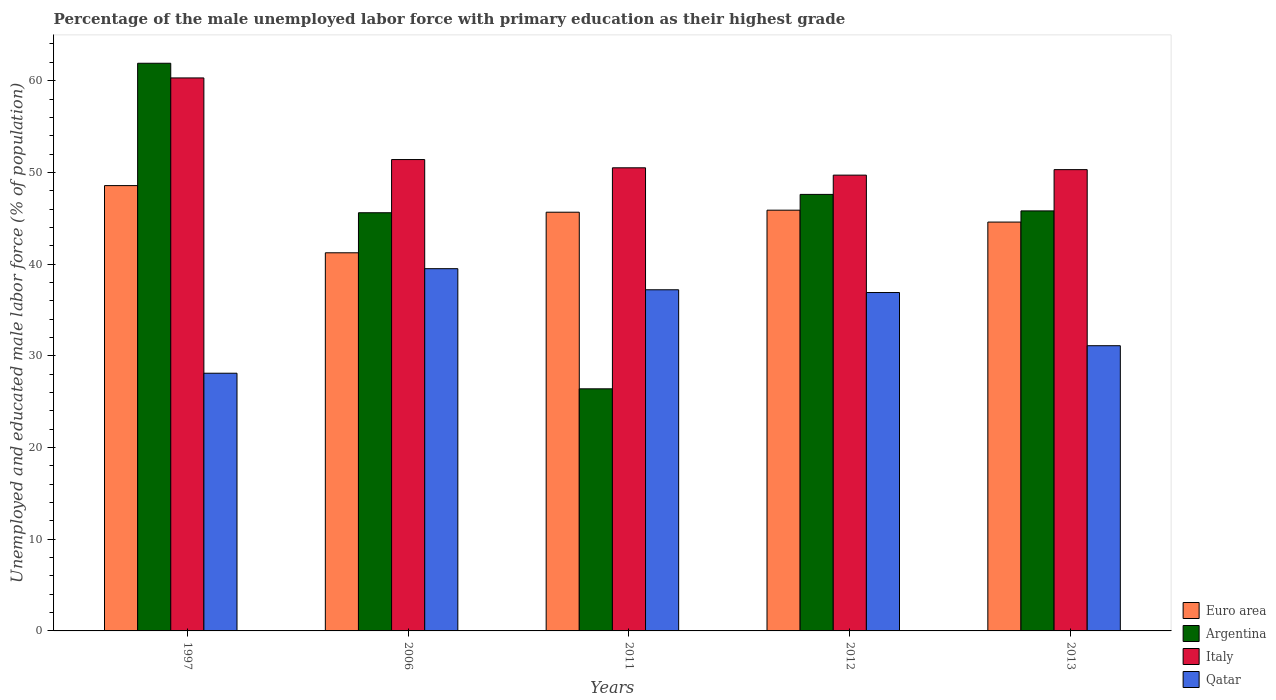How many different coloured bars are there?
Give a very brief answer. 4. How many groups of bars are there?
Offer a terse response. 5. Are the number of bars per tick equal to the number of legend labels?
Offer a terse response. Yes. How many bars are there on the 4th tick from the left?
Provide a short and direct response. 4. In how many cases, is the number of bars for a given year not equal to the number of legend labels?
Your answer should be compact. 0. What is the percentage of the unemployed male labor force with primary education in Euro area in 2013?
Your answer should be very brief. 44.58. Across all years, what is the maximum percentage of the unemployed male labor force with primary education in Argentina?
Your answer should be very brief. 61.9. Across all years, what is the minimum percentage of the unemployed male labor force with primary education in Qatar?
Provide a succinct answer. 28.1. In which year was the percentage of the unemployed male labor force with primary education in Qatar minimum?
Offer a very short reply. 1997. What is the total percentage of the unemployed male labor force with primary education in Italy in the graph?
Keep it short and to the point. 262.2. What is the difference between the percentage of the unemployed male labor force with primary education in Qatar in 1997 and that in 2012?
Provide a succinct answer. -8.8. What is the difference between the percentage of the unemployed male labor force with primary education in Euro area in 2006 and the percentage of the unemployed male labor force with primary education in Italy in 2013?
Your answer should be compact. -9.07. What is the average percentage of the unemployed male labor force with primary education in Italy per year?
Your answer should be compact. 52.44. In the year 2006, what is the difference between the percentage of the unemployed male labor force with primary education in Qatar and percentage of the unemployed male labor force with primary education in Italy?
Your answer should be very brief. -11.9. What is the ratio of the percentage of the unemployed male labor force with primary education in Euro area in 2011 to that in 2012?
Keep it short and to the point. 1. Is the percentage of the unemployed male labor force with primary education in Italy in 2012 less than that in 2013?
Offer a very short reply. Yes. What is the difference between the highest and the second highest percentage of the unemployed male labor force with primary education in Qatar?
Give a very brief answer. 2.3. What is the difference between the highest and the lowest percentage of the unemployed male labor force with primary education in Italy?
Your answer should be very brief. 10.6. In how many years, is the percentage of the unemployed male labor force with primary education in Qatar greater than the average percentage of the unemployed male labor force with primary education in Qatar taken over all years?
Offer a very short reply. 3. Is the sum of the percentage of the unemployed male labor force with primary education in Qatar in 2012 and 2013 greater than the maximum percentage of the unemployed male labor force with primary education in Italy across all years?
Give a very brief answer. Yes. What does the 1st bar from the left in 2006 represents?
Your answer should be very brief. Euro area. What does the 2nd bar from the right in 1997 represents?
Your answer should be very brief. Italy. Is it the case that in every year, the sum of the percentage of the unemployed male labor force with primary education in Italy and percentage of the unemployed male labor force with primary education in Argentina is greater than the percentage of the unemployed male labor force with primary education in Euro area?
Offer a terse response. Yes. How many bars are there?
Give a very brief answer. 20. Are all the bars in the graph horizontal?
Offer a very short reply. No. Does the graph contain any zero values?
Give a very brief answer. No. Does the graph contain grids?
Keep it short and to the point. No. How many legend labels are there?
Give a very brief answer. 4. How are the legend labels stacked?
Your answer should be compact. Vertical. What is the title of the graph?
Your response must be concise. Percentage of the male unemployed labor force with primary education as their highest grade. Does "Peru" appear as one of the legend labels in the graph?
Your response must be concise. No. What is the label or title of the X-axis?
Provide a succinct answer. Years. What is the label or title of the Y-axis?
Offer a very short reply. Unemployed and educated male labor force (% of population). What is the Unemployed and educated male labor force (% of population) of Euro area in 1997?
Your response must be concise. 48.56. What is the Unemployed and educated male labor force (% of population) in Argentina in 1997?
Provide a succinct answer. 61.9. What is the Unemployed and educated male labor force (% of population) of Italy in 1997?
Your answer should be very brief. 60.3. What is the Unemployed and educated male labor force (% of population) of Qatar in 1997?
Provide a succinct answer. 28.1. What is the Unemployed and educated male labor force (% of population) in Euro area in 2006?
Offer a very short reply. 41.23. What is the Unemployed and educated male labor force (% of population) of Argentina in 2006?
Provide a short and direct response. 45.6. What is the Unemployed and educated male labor force (% of population) of Italy in 2006?
Offer a terse response. 51.4. What is the Unemployed and educated male labor force (% of population) of Qatar in 2006?
Your answer should be very brief. 39.5. What is the Unemployed and educated male labor force (% of population) in Euro area in 2011?
Your answer should be very brief. 45.66. What is the Unemployed and educated male labor force (% of population) of Argentina in 2011?
Keep it short and to the point. 26.4. What is the Unemployed and educated male labor force (% of population) in Italy in 2011?
Your answer should be very brief. 50.5. What is the Unemployed and educated male labor force (% of population) in Qatar in 2011?
Your response must be concise. 37.2. What is the Unemployed and educated male labor force (% of population) in Euro area in 2012?
Give a very brief answer. 45.88. What is the Unemployed and educated male labor force (% of population) of Argentina in 2012?
Provide a succinct answer. 47.6. What is the Unemployed and educated male labor force (% of population) of Italy in 2012?
Your answer should be compact. 49.7. What is the Unemployed and educated male labor force (% of population) of Qatar in 2012?
Your response must be concise. 36.9. What is the Unemployed and educated male labor force (% of population) of Euro area in 2013?
Make the answer very short. 44.58. What is the Unemployed and educated male labor force (% of population) of Argentina in 2013?
Ensure brevity in your answer.  45.8. What is the Unemployed and educated male labor force (% of population) of Italy in 2013?
Give a very brief answer. 50.3. What is the Unemployed and educated male labor force (% of population) of Qatar in 2013?
Your answer should be very brief. 31.1. Across all years, what is the maximum Unemployed and educated male labor force (% of population) in Euro area?
Make the answer very short. 48.56. Across all years, what is the maximum Unemployed and educated male labor force (% of population) of Argentina?
Give a very brief answer. 61.9. Across all years, what is the maximum Unemployed and educated male labor force (% of population) in Italy?
Provide a succinct answer. 60.3. Across all years, what is the maximum Unemployed and educated male labor force (% of population) of Qatar?
Offer a terse response. 39.5. Across all years, what is the minimum Unemployed and educated male labor force (% of population) of Euro area?
Provide a short and direct response. 41.23. Across all years, what is the minimum Unemployed and educated male labor force (% of population) of Argentina?
Make the answer very short. 26.4. Across all years, what is the minimum Unemployed and educated male labor force (% of population) of Italy?
Your answer should be very brief. 49.7. Across all years, what is the minimum Unemployed and educated male labor force (% of population) of Qatar?
Your response must be concise. 28.1. What is the total Unemployed and educated male labor force (% of population) in Euro area in the graph?
Your response must be concise. 225.91. What is the total Unemployed and educated male labor force (% of population) of Argentina in the graph?
Your response must be concise. 227.3. What is the total Unemployed and educated male labor force (% of population) in Italy in the graph?
Provide a succinct answer. 262.2. What is the total Unemployed and educated male labor force (% of population) of Qatar in the graph?
Keep it short and to the point. 172.8. What is the difference between the Unemployed and educated male labor force (% of population) of Euro area in 1997 and that in 2006?
Provide a short and direct response. 7.33. What is the difference between the Unemployed and educated male labor force (% of population) in Argentina in 1997 and that in 2006?
Make the answer very short. 16.3. What is the difference between the Unemployed and educated male labor force (% of population) of Italy in 1997 and that in 2006?
Make the answer very short. 8.9. What is the difference between the Unemployed and educated male labor force (% of population) of Qatar in 1997 and that in 2006?
Provide a short and direct response. -11.4. What is the difference between the Unemployed and educated male labor force (% of population) of Euro area in 1997 and that in 2011?
Your response must be concise. 2.9. What is the difference between the Unemployed and educated male labor force (% of population) in Argentina in 1997 and that in 2011?
Your answer should be very brief. 35.5. What is the difference between the Unemployed and educated male labor force (% of population) of Euro area in 1997 and that in 2012?
Ensure brevity in your answer.  2.68. What is the difference between the Unemployed and educated male labor force (% of population) of Italy in 1997 and that in 2012?
Ensure brevity in your answer.  10.6. What is the difference between the Unemployed and educated male labor force (% of population) in Qatar in 1997 and that in 2012?
Your response must be concise. -8.8. What is the difference between the Unemployed and educated male labor force (% of population) of Euro area in 1997 and that in 2013?
Ensure brevity in your answer.  3.98. What is the difference between the Unemployed and educated male labor force (% of population) of Argentina in 1997 and that in 2013?
Keep it short and to the point. 16.1. What is the difference between the Unemployed and educated male labor force (% of population) of Euro area in 2006 and that in 2011?
Provide a succinct answer. -4.42. What is the difference between the Unemployed and educated male labor force (% of population) in Argentina in 2006 and that in 2011?
Make the answer very short. 19.2. What is the difference between the Unemployed and educated male labor force (% of population) in Qatar in 2006 and that in 2011?
Keep it short and to the point. 2.3. What is the difference between the Unemployed and educated male labor force (% of population) of Euro area in 2006 and that in 2012?
Your response must be concise. -4.65. What is the difference between the Unemployed and educated male labor force (% of population) of Argentina in 2006 and that in 2012?
Keep it short and to the point. -2. What is the difference between the Unemployed and educated male labor force (% of population) of Italy in 2006 and that in 2012?
Keep it short and to the point. 1.7. What is the difference between the Unemployed and educated male labor force (% of population) in Qatar in 2006 and that in 2012?
Your answer should be compact. 2.6. What is the difference between the Unemployed and educated male labor force (% of population) in Euro area in 2006 and that in 2013?
Ensure brevity in your answer.  -3.35. What is the difference between the Unemployed and educated male labor force (% of population) in Argentina in 2006 and that in 2013?
Your response must be concise. -0.2. What is the difference between the Unemployed and educated male labor force (% of population) in Italy in 2006 and that in 2013?
Your answer should be compact. 1.1. What is the difference between the Unemployed and educated male labor force (% of population) in Qatar in 2006 and that in 2013?
Ensure brevity in your answer.  8.4. What is the difference between the Unemployed and educated male labor force (% of population) of Euro area in 2011 and that in 2012?
Your answer should be very brief. -0.22. What is the difference between the Unemployed and educated male labor force (% of population) of Argentina in 2011 and that in 2012?
Offer a terse response. -21.2. What is the difference between the Unemployed and educated male labor force (% of population) of Italy in 2011 and that in 2012?
Your answer should be very brief. 0.8. What is the difference between the Unemployed and educated male labor force (% of population) in Qatar in 2011 and that in 2012?
Provide a succinct answer. 0.3. What is the difference between the Unemployed and educated male labor force (% of population) of Euro area in 2011 and that in 2013?
Your answer should be compact. 1.08. What is the difference between the Unemployed and educated male labor force (% of population) in Argentina in 2011 and that in 2013?
Your answer should be very brief. -19.4. What is the difference between the Unemployed and educated male labor force (% of population) of Euro area in 2012 and that in 2013?
Your response must be concise. 1.3. What is the difference between the Unemployed and educated male labor force (% of population) of Argentina in 2012 and that in 2013?
Give a very brief answer. 1.8. What is the difference between the Unemployed and educated male labor force (% of population) in Italy in 2012 and that in 2013?
Give a very brief answer. -0.6. What is the difference between the Unemployed and educated male labor force (% of population) of Euro area in 1997 and the Unemployed and educated male labor force (% of population) of Argentina in 2006?
Give a very brief answer. 2.96. What is the difference between the Unemployed and educated male labor force (% of population) in Euro area in 1997 and the Unemployed and educated male labor force (% of population) in Italy in 2006?
Make the answer very short. -2.84. What is the difference between the Unemployed and educated male labor force (% of population) in Euro area in 1997 and the Unemployed and educated male labor force (% of population) in Qatar in 2006?
Your answer should be compact. 9.06. What is the difference between the Unemployed and educated male labor force (% of population) of Argentina in 1997 and the Unemployed and educated male labor force (% of population) of Italy in 2006?
Your response must be concise. 10.5. What is the difference between the Unemployed and educated male labor force (% of population) of Argentina in 1997 and the Unemployed and educated male labor force (% of population) of Qatar in 2006?
Offer a terse response. 22.4. What is the difference between the Unemployed and educated male labor force (% of population) in Italy in 1997 and the Unemployed and educated male labor force (% of population) in Qatar in 2006?
Your answer should be very brief. 20.8. What is the difference between the Unemployed and educated male labor force (% of population) in Euro area in 1997 and the Unemployed and educated male labor force (% of population) in Argentina in 2011?
Your response must be concise. 22.16. What is the difference between the Unemployed and educated male labor force (% of population) in Euro area in 1997 and the Unemployed and educated male labor force (% of population) in Italy in 2011?
Your answer should be very brief. -1.94. What is the difference between the Unemployed and educated male labor force (% of population) in Euro area in 1997 and the Unemployed and educated male labor force (% of population) in Qatar in 2011?
Ensure brevity in your answer.  11.36. What is the difference between the Unemployed and educated male labor force (% of population) in Argentina in 1997 and the Unemployed and educated male labor force (% of population) in Italy in 2011?
Ensure brevity in your answer.  11.4. What is the difference between the Unemployed and educated male labor force (% of population) in Argentina in 1997 and the Unemployed and educated male labor force (% of population) in Qatar in 2011?
Offer a very short reply. 24.7. What is the difference between the Unemployed and educated male labor force (% of population) in Italy in 1997 and the Unemployed and educated male labor force (% of population) in Qatar in 2011?
Provide a short and direct response. 23.1. What is the difference between the Unemployed and educated male labor force (% of population) of Euro area in 1997 and the Unemployed and educated male labor force (% of population) of Argentina in 2012?
Provide a succinct answer. 0.96. What is the difference between the Unemployed and educated male labor force (% of population) of Euro area in 1997 and the Unemployed and educated male labor force (% of population) of Italy in 2012?
Your response must be concise. -1.14. What is the difference between the Unemployed and educated male labor force (% of population) in Euro area in 1997 and the Unemployed and educated male labor force (% of population) in Qatar in 2012?
Your answer should be compact. 11.66. What is the difference between the Unemployed and educated male labor force (% of population) in Argentina in 1997 and the Unemployed and educated male labor force (% of population) in Qatar in 2012?
Ensure brevity in your answer.  25. What is the difference between the Unemployed and educated male labor force (% of population) of Italy in 1997 and the Unemployed and educated male labor force (% of population) of Qatar in 2012?
Ensure brevity in your answer.  23.4. What is the difference between the Unemployed and educated male labor force (% of population) in Euro area in 1997 and the Unemployed and educated male labor force (% of population) in Argentina in 2013?
Your answer should be compact. 2.76. What is the difference between the Unemployed and educated male labor force (% of population) of Euro area in 1997 and the Unemployed and educated male labor force (% of population) of Italy in 2013?
Offer a terse response. -1.74. What is the difference between the Unemployed and educated male labor force (% of population) in Euro area in 1997 and the Unemployed and educated male labor force (% of population) in Qatar in 2013?
Ensure brevity in your answer.  17.46. What is the difference between the Unemployed and educated male labor force (% of population) of Argentina in 1997 and the Unemployed and educated male labor force (% of population) of Qatar in 2013?
Give a very brief answer. 30.8. What is the difference between the Unemployed and educated male labor force (% of population) of Italy in 1997 and the Unemployed and educated male labor force (% of population) of Qatar in 2013?
Give a very brief answer. 29.2. What is the difference between the Unemployed and educated male labor force (% of population) in Euro area in 2006 and the Unemployed and educated male labor force (% of population) in Argentina in 2011?
Offer a terse response. 14.83. What is the difference between the Unemployed and educated male labor force (% of population) of Euro area in 2006 and the Unemployed and educated male labor force (% of population) of Italy in 2011?
Your response must be concise. -9.27. What is the difference between the Unemployed and educated male labor force (% of population) in Euro area in 2006 and the Unemployed and educated male labor force (% of population) in Qatar in 2011?
Ensure brevity in your answer.  4.03. What is the difference between the Unemployed and educated male labor force (% of population) in Argentina in 2006 and the Unemployed and educated male labor force (% of population) in Italy in 2011?
Offer a very short reply. -4.9. What is the difference between the Unemployed and educated male labor force (% of population) of Italy in 2006 and the Unemployed and educated male labor force (% of population) of Qatar in 2011?
Your answer should be compact. 14.2. What is the difference between the Unemployed and educated male labor force (% of population) of Euro area in 2006 and the Unemployed and educated male labor force (% of population) of Argentina in 2012?
Your response must be concise. -6.37. What is the difference between the Unemployed and educated male labor force (% of population) in Euro area in 2006 and the Unemployed and educated male labor force (% of population) in Italy in 2012?
Give a very brief answer. -8.47. What is the difference between the Unemployed and educated male labor force (% of population) of Euro area in 2006 and the Unemployed and educated male labor force (% of population) of Qatar in 2012?
Provide a short and direct response. 4.33. What is the difference between the Unemployed and educated male labor force (% of population) of Argentina in 2006 and the Unemployed and educated male labor force (% of population) of Qatar in 2012?
Your answer should be very brief. 8.7. What is the difference between the Unemployed and educated male labor force (% of population) in Euro area in 2006 and the Unemployed and educated male labor force (% of population) in Argentina in 2013?
Ensure brevity in your answer.  -4.57. What is the difference between the Unemployed and educated male labor force (% of population) of Euro area in 2006 and the Unemployed and educated male labor force (% of population) of Italy in 2013?
Your answer should be very brief. -9.07. What is the difference between the Unemployed and educated male labor force (% of population) in Euro area in 2006 and the Unemployed and educated male labor force (% of population) in Qatar in 2013?
Make the answer very short. 10.13. What is the difference between the Unemployed and educated male labor force (% of population) of Argentina in 2006 and the Unemployed and educated male labor force (% of population) of Qatar in 2013?
Offer a terse response. 14.5. What is the difference between the Unemployed and educated male labor force (% of population) of Italy in 2006 and the Unemployed and educated male labor force (% of population) of Qatar in 2013?
Offer a very short reply. 20.3. What is the difference between the Unemployed and educated male labor force (% of population) of Euro area in 2011 and the Unemployed and educated male labor force (% of population) of Argentina in 2012?
Offer a very short reply. -1.94. What is the difference between the Unemployed and educated male labor force (% of population) in Euro area in 2011 and the Unemployed and educated male labor force (% of population) in Italy in 2012?
Give a very brief answer. -4.04. What is the difference between the Unemployed and educated male labor force (% of population) in Euro area in 2011 and the Unemployed and educated male labor force (% of population) in Qatar in 2012?
Offer a terse response. 8.76. What is the difference between the Unemployed and educated male labor force (% of population) in Argentina in 2011 and the Unemployed and educated male labor force (% of population) in Italy in 2012?
Offer a terse response. -23.3. What is the difference between the Unemployed and educated male labor force (% of population) in Italy in 2011 and the Unemployed and educated male labor force (% of population) in Qatar in 2012?
Give a very brief answer. 13.6. What is the difference between the Unemployed and educated male labor force (% of population) in Euro area in 2011 and the Unemployed and educated male labor force (% of population) in Argentina in 2013?
Ensure brevity in your answer.  -0.14. What is the difference between the Unemployed and educated male labor force (% of population) in Euro area in 2011 and the Unemployed and educated male labor force (% of population) in Italy in 2013?
Your response must be concise. -4.64. What is the difference between the Unemployed and educated male labor force (% of population) of Euro area in 2011 and the Unemployed and educated male labor force (% of population) of Qatar in 2013?
Ensure brevity in your answer.  14.56. What is the difference between the Unemployed and educated male labor force (% of population) of Argentina in 2011 and the Unemployed and educated male labor force (% of population) of Italy in 2013?
Offer a very short reply. -23.9. What is the difference between the Unemployed and educated male labor force (% of population) in Argentina in 2011 and the Unemployed and educated male labor force (% of population) in Qatar in 2013?
Ensure brevity in your answer.  -4.7. What is the difference between the Unemployed and educated male labor force (% of population) of Euro area in 2012 and the Unemployed and educated male labor force (% of population) of Argentina in 2013?
Your response must be concise. 0.08. What is the difference between the Unemployed and educated male labor force (% of population) of Euro area in 2012 and the Unemployed and educated male labor force (% of population) of Italy in 2013?
Offer a terse response. -4.42. What is the difference between the Unemployed and educated male labor force (% of population) of Euro area in 2012 and the Unemployed and educated male labor force (% of population) of Qatar in 2013?
Keep it short and to the point. 14.78. What is the difference between the Unemployed and educated male labor force (% of population) of Argentina in 2012 and the Unemployed and educated male labor force (% of population) of Italy in 2013?
Your response must be concise. -2.7. What is the difference between the Unemployed and educated male labor force (% of population) in Argentina in 2012 and the Unemployed and educated male labor force (% of population) in Qatar in 2013?
Provide a succinct answer. 16.5. What is the difference between the Unemployed and educated male labor force (% of population) in Italy in 2012 and the Unemployed and educated male labor force (% of population) in Qatar in 2013?
Offer a very short reply. 18.6. What is the average Unemployed and educated male labor force (% of population) in Euro area per year?
Make the answer very short. 45.18. What is the average Unemployed and educated male labor force (% of population) of Argentina per year?
Offer a terse response. 45.46. What is the average Unemployed and educated male labor force (% of population) in Italy per year?
Provide a succinct answer. 52.44. What is the average Unemployed and educated male labor force (% of population) in Qatar per year?
Provide a short and direct response. 34.56. In the year 1997, what is the difference between the Unemployed and educated male labor force (% of population) in Euro area and Unemployed and educated male labor force (% of population) in Argentina?
Provide a short and direct response. -13.34. In the year 1997, what is the difference between the Unemployed and educated male labor force (% of population) in Euro area and Unemployed and educated male labor force (% of population) in Italy?
Keep it short and to the point. -11.74. In the year 1997, what is the difference between the Unemployed and educated male labor force (% of population) in Euro area and Unemployed and educated male labor force (% of population) in Qatar?
Keep it short and to the point. 20.46. In the year 1997, what is the difference between the Unemployed and educated male labor force (% of population) in Argentina and Unemployed and educated male labor force (% of population) in Qatar?
Ensure brevity in your answer.  33.8. In the year 1997, what is the difference between the Unemployed and educated male labor force (% of population) of Italy and Unemployed and educated male labor force (% of population) of Qatar?
Give a very brief answer. 32.2. In the year 2006, what is the difference between the Unemployed and educated male labor force (% of population) in Euro area and Unemployed and educated male labor force (% of population) in Argentina?
Keep it short and to the point. -4.37. In the year 2006, what is the difference between the Unemployed and educated male labor force (% of population) of Euro area and Unemployed and educated male labor force (% of population) of Italy?
Your response must be concise. -10.17. In the year 2006, what is the difference between the Unemployed and educated male labor force (% of population) of Euro area and Unemployed and educated male labor force (% of population) of Qatar?
Your answer should be very brief. 1.73. In the year 2006, what is the difference between the Unemployed and educated male labor force (% of population) of Argentina and Unemployed and educated male labor force (% of population) of Qatar?
Offer a very short reply. 6.1. In the year 2006, what is the difference between the Unemployed and educated male labor force (% of population) in Italy and Unemployed and educated male labor force (% of population) in Qatar?
Offer a terse response. 11.9. In the year 2011, what is the difference between the Unemployed and educated male labor force (% of population) in Euro area and Unemployed and educated male labor force (% of population) in Argentina?
Give a very brief answer. 19.26. In the year 2011, what is the difference between the Unemployed and educated male labor force (% of population) of Euro area and Unemployed and educated male labor force (% of population) of Italy?
Ensure brevity in your answer.  -4.84. In the year 2011, what is the difference between the Unemployed and educated male labor force (% of population) of Euro area and Unemployed and educated male labor force (% of population) of Qatar?
Your answer should be very brief. 8.46. In the year 2011, what is the difference between the Unemployed and educated male labor force (% of population) in Argentina and Unemployed and educated male labor force (% of population) in Italy?
Your answer should be very brief. -24.1. In the year 2012, what is the difference between the Unemployed and educated male labor force (% of population) in Euro area and Unemployed and educated male labor force (% of population) in Argentina?
Give a very brief answer. -1.72. In the year 2012, what is the difference between the Unemployed and educated male labor force (% of population) of Euro area and Unemployed and educated male labor force (% of population) of Italy?
Provide a short and direct response. -3.82. In the year 2012, what is the difference between the Unemployed and educated male labor force (% of population) in Euro area and Unemployed and educated male labor force (% of population) in Qatar?
Keep it short and to the point. 8.98. In the year 2012, what is the difference between the Unemployed and educated male labor force (% of population) of Argentina and Unemployed and educated male labor force (% of population) of Italy?
Keep it short and to the point. -2.1. In the year 2012, what is the difference between the Unemployed and educated male labor force (% of population) of Argentina and Unemployed and educated male labor force (% of population) of Qatar?
Your answer should be very brief. 10.7. In the year 2012, what is the difference between the Unemployed and educated male labor force (% of population) of Italy and Unemployed and educated male labor force (% of population) of Qatar?
Your answer should be compact. 12.8. In the year 2013, what is the difference between the Unemployed and educated male labor force (% of population) of Euro area and Unemployed and educated male labor force (% of population) of Argentina?
Offer a very short reply. -1.22. In the year 2013, what is the difference between the Unemployed and educated male labor force (% of population) in Euro area and Unemployed and educated male labor force (% of population) in Italy?
Ensure brevity in your answer.  -5.72. In the year 2013, what is the difference between the Unemployed and educated male labor force (% of population) in Euro area and Unemployed and educated male labor force (% of population) in Qatar?
Ensure brevity in your answer.  13.48. What is the ratio of the Unemployed and educated male labor force (% of population) of Euro area in 1997 to that in 2006?
Ensure brevity in your answer.  1.18. What is the ratio of the Unemployed and educated male labor force (% of population) of Argentina in 1997 to that in 2006?
Your answer should be very brief. 1.36. What is the ratio of the Unemployed and educated male labor force (% of population) in Italy in 1997 to that in 2006?
Give a very brief answer. 1.17. What is the ratio of the Unemployed and educated male labor force (% of population) of Qatar in 1997 to that in 2006?
Your answer should be very brief. 0.71. What is the ratio of the Unemployed and educated male labor force (% of population) of Euro area in 1997 to that in 2011?
Offer a very short reply. 1.06. What is the ratio of the Unemployed and educated male labor force (% of population) of Argentina in 1997 to that in 2011?
Your answer should be compact. 2.34. What is the ratio of the Unemployed and educated male labor force (% of population) of Italy in 1997 to that in 2011?
Your answer should be very brief. 1.19. What is the ratio of the Unemployed and educated male labor force (% of population) in Qatar in 1997 to that in 2011?
Your answer should be very brief. 0.76. What is the ratio of the Unemployed and educated male labor force (% of population) of Euro area in 1997 to that in 2012?
Your response must be concise. 1.06. What is the ratio of the Unemployed and educated male labor force (% of population) in Argentina in 1997 to that in 2012?
Offer a terse response. 1.3. What is the ratio of the Unemployed and educated male labor force (% of population) of Italy in 1997 to that in 2012?
Your answer should be very brief. 1.21. What is the ratio of the Unemployed and educated male labor force (% of population) of Qatar in 1997 to that in 2012?
Ensure brevity in your answer.  0.76. What is the ratio of the Unemployed and educated male labor force (% of population) in Euro area in 1997 to that in 2013?
Your answer should be very brief. 1.09. What is the ratio of the Unemployed and educated male labor force (% of population) of Argentina in 1997 to that in 2013?
Your answer should be very brief. 1.35. What is the ratio of the Unemployed and educated male labor force (% of population) of Italy in 1997 to that in 2013?
Your response must be concise. 1.2. What is the ratio of the Unemployed and educated male labor force (% of population) in Qatar in 1997 to that in 2013?
Make the answer very short. 0.9. What is the ratio of the Unemployed and educated male labor force (% of population) in Euro area in 2006 to that in 2011?
Give a very brief answer. 0.9. What is the ratio of the Unemployed and educated male labor force (% of population) of Argentina in 2006 to that in 2011?
Provide a short and direct response. 1.73. What is the ratio of the Unemployed and educated male labor force (% of population) of Italy in 2006 to that in 2011?
Give a very brief answer. 1.02. What is the ratio of the Unemployed and educated male labor force (% of population) in Qatar in 2006 to that in 2011?
Offer a very short reply. 1.06. What is the ratio of the Unemployed and educated male labor force (% of population) of Euro area in 2006 to that in 2012?
Provide a succinct answer. 0.9. What is the ratio of the Unemployed and educated male labor force (% of population) in Argentina in 2006 to that in 2012?
Offer a very short reply. 0.96. What is the ratio of the Unemployed and educated male labor force (% of population) in Italy in 2006 to that in 2012?
Ensure brevity in your answer.  1.03. What is the ratio of the Unemployed and educated male labor force (% of population) in Qatar in 2006 to that in 2012?
Your response must be concise. 1.07. What is the ratio of the Unemployed and educated male labor force (% of population) of Euro area in 2006 to that in 2013?
Provide a succinct answer. 0.92. What is the ratio of the Unemployed and educated male labor force (% of population) in Argentina in 2006 to that in 2013?
Provide a succinct answer. 1. What is the ratio of the Unemployed and educated male labor force (% of population) in Italy in 2006 to that in 2013?
Your response must be concise. 1.02. What is the ratio of the Unemployed and educated male labor force (% of population) in Qatar in 2006 to that in 2013?
Ensure brevity in your answer.  1.27. What is the ratio of the Unemployed and educated male labor force (% of population) of Euro area in 2011 to that in 2012?
Make the answer very short. 1. What is the ratio of the Unemployed and educated male labor force (% of population) of Argentina in 2011 to that in 2012?
Provide a short and direct response. 0.55. What is the ratio of the Unemployed and educated male labor force (% of population) in Italy in 2011 to that in 2012?
Give a very brief answer. 1.02. What is the ratio of the Unemployed and educated male labor force (% of population) of Euro area in 2011 to that in 2013?
Your response must be concise. 1.02. What is the ratio of the Unemployed and educated male labor force (% of population) of Argentina in 2011 to that in 2013?
Give a very brief answer. 0.58. What is the ratio of the Unemployed and educated male labor force (% of population) of Italy in 2011 to that in 2013?
Your answer should be compact. 1. What is the ratio of the Unemployed and educated male labor force (% of population) in Qatar in 2011 to that in 2013?
Offer a very short reply. 1.2. What is the ratio of the Unemployed and educated male labor force (% of population) of Euro area in 2012 to that in 2013?
Give a very brief answer. 1.03. What is the ratio of the Unemployed and educated male labor force (% of population) in Argentina in 2012 to that in 2013?
Ensure brevity in your answer.  1.04. What is the ratio of the Unemployed and educated male labor force (% of population) in Italy in 2012 to that in 2013?
Give a very brief answer. 0.99. What is the ratio of the Unemployed and educated male labor force (% of population) of Qatar in 2012 to that in 2013?
Give a very brief answer. 1.19. What is the difference between the highest and the second highest Unemployed and educated male labor force (% of population) in Euro area?
Give a very brief answer. 2.68. What is the difference between the highest and the second highest Unemployed and educated male labor force (% of population) in Argentina?
Give a very brief answer. 14.3. What is the difference between the highest and the second highest Unemployed and educated male labor force (% of population) in Italy?
Your response must be concise. 8.9. What is the difference between the highest and the second highest Unemployed and educated male labor force (% of population) in Qatar?
Make the answer very short. 2.3. What is the difference between the highest and the lowest Unemployed and educated male labor force (% of population) of Euro area?
Your answer should be very brief. 7.33. What is the difference between the highest and the lowest Unemployed and educated male labor force (% of population) of Argentina?
Your answer should be very brief. 35.5. 